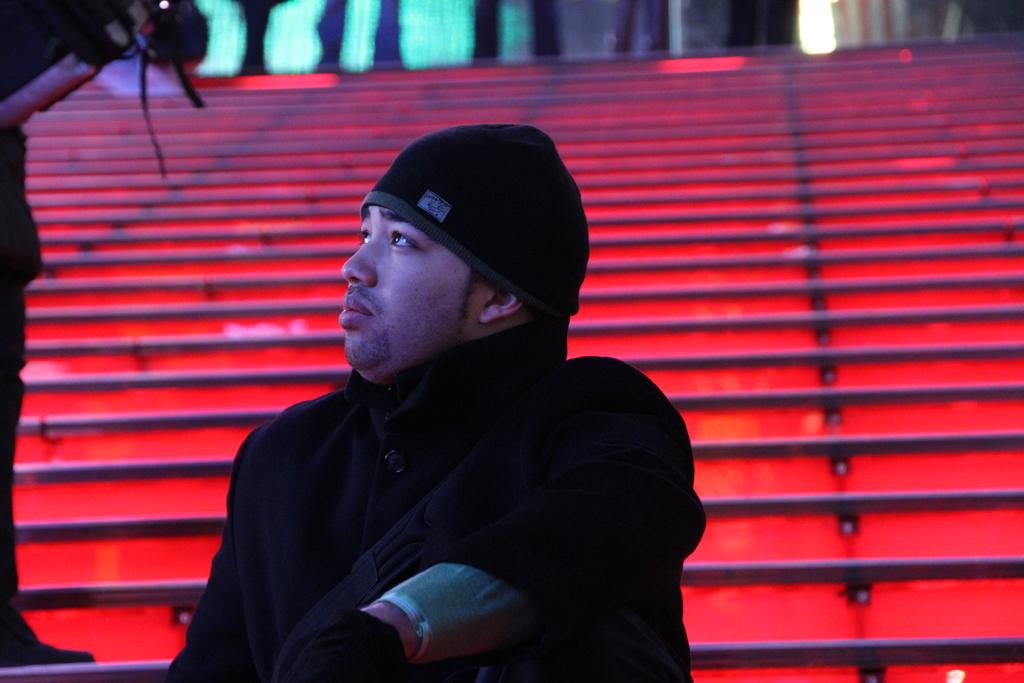What type of structure is visible in the image? There are stairs in the image. How many people are present in the image? There are two people in the image. Can you describe one of the people in the image? One of the people is a man. What is the man wearing in the image? The man is wearing a black dress. What type of system is the man using to purchase a ticket in the image? There is no system or ticket present in the image; it only features stairs and two people, one of whom is a man wearing a black dress. 